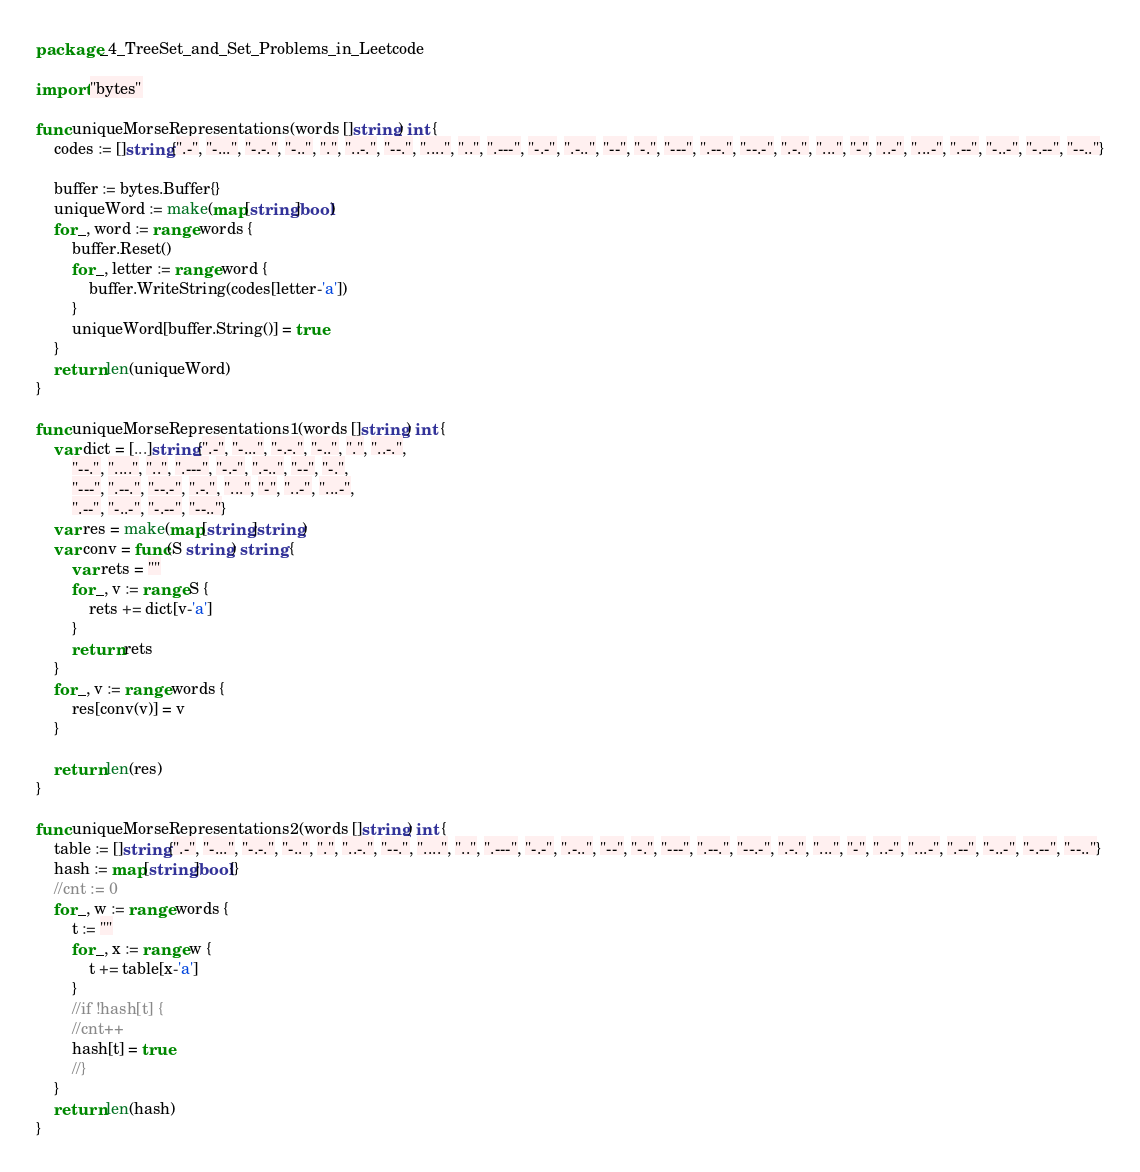Convert code to text. <code><loc_0><loc_0><loc_500><loc_500><_Go_>package _4_TreeSet_and_Set_Problems_in_Leetcode

import "bytes"

func uniqueMorseRepresentations(words []string) int {
	codes := []string{".-", "-...", "-.-.", "-..", ".", "..-.", "--.", "....", "..", ".---", "-.-", ".-..", "--", "-.", "---", ".--.", "--.-", ".-.", "...", "-", "..-", "...-", ".--", "-..-", "-.--", "--.."}

	buffer := bytes.Buffer{}
	uniqueWord := make(map[string]bool)
	for _, word := range words {
		buffer.Reset()
		for _, letter := range word {
			buffer.WriteString(codes[letter-'a'])
		}
		uniqueWord[buffer.String()] = true
	}
	return len(uniqueWord)
}

func uniqueMorseRepresentations1(words []string) int {
	var dict = [...]string{".-", "-...", "-.-.", "-..", ".", "..-.",
		"--.", "....", "..", ".---", "-.-", ".-..", "--", "-.",
		"---", ".--.", "--.-", ".-.", "...", "-", "..-", "...-",
		".--", "-..-", "-.--", "--.."}
	var res = make(map[string]string)
	var conv = func(S string) string {
		var rets = ""
		for _, v := range S {
			rets += dict[v-'a']
		}
		return rets
	}
	for _, v := range words {
		res[conv(v)] = v
	}

	return len(res)
}

func uniqueMorseRepresentations2(words []string) int {
	table := []string{".-", "-...", "-.-.", "-..", ".", "..-.", "--.", "....", "..", ".---", "-.-", ".-..", "--", "-.", "---", ".--.", "--.-", ".-.", "...", "-", "..-", "...-", ".--", "-..-", "-.--", "--.."}
	hash := map[string]bool{}
	//cnt := 0
	for _, w := range words {
		t := ""
		for _, x := range w {
			t += table[x-'a']
		}
		//if !hash[t] {
		//cnt++
		hash[t] = true
		//}
	}
	return len(hash)
}
</code> 